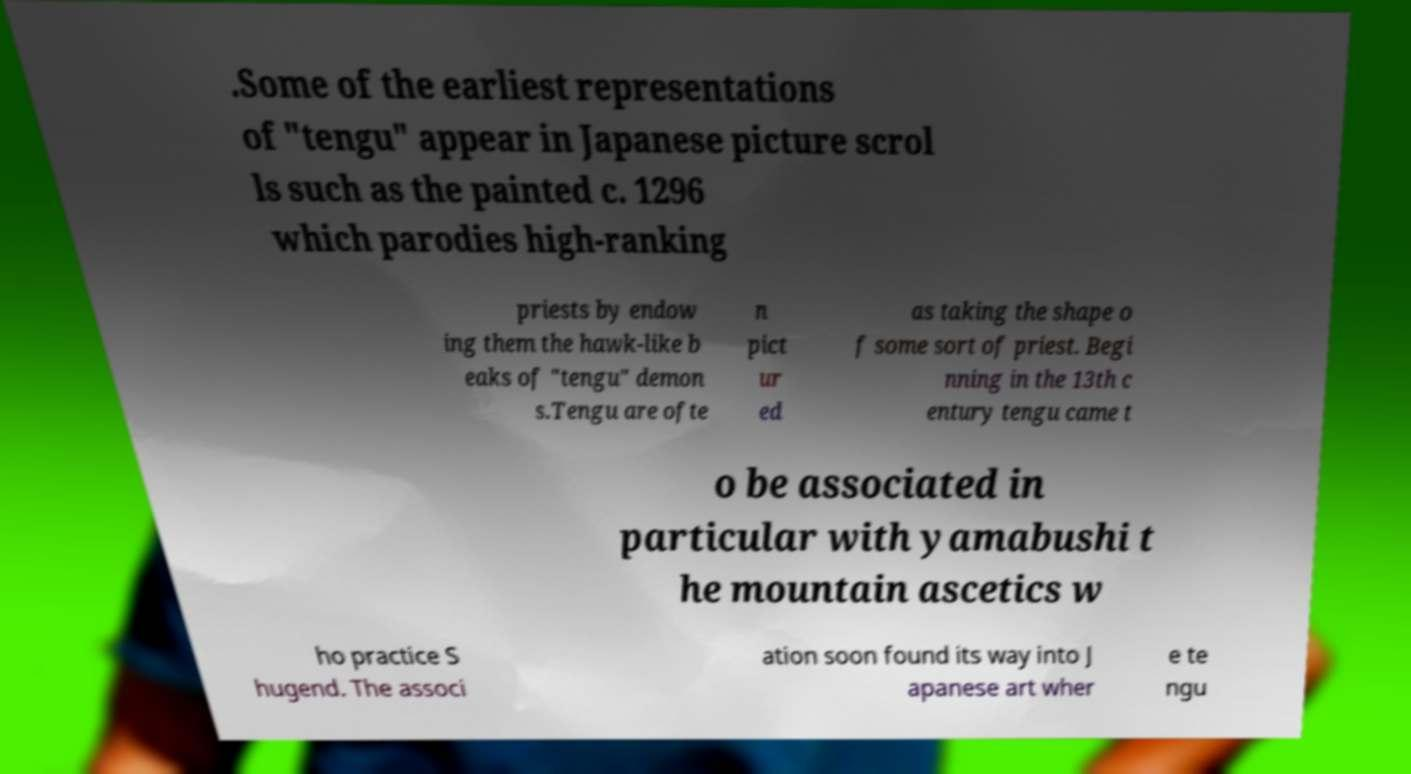There's text embedded in this image that I need extracted. Can you transcribe it verbatim? .Some of the earliest representations of "tengu" appear in Japanese picture scrol ls such as the painted c. 1296 which parodies high-ranking priests by endow ing them the hawk-like b eaks of "tengu" demon s.Tengu are ofte n pict ur ed as taking the shape o f some sort of priest. Begi nning in the 13th c entury tengu came t o be associated in particular with yamabushi t he mountain ascetics w ho practice S hugend. The associ ation soon found its way into J apanese art wher e te ngu 